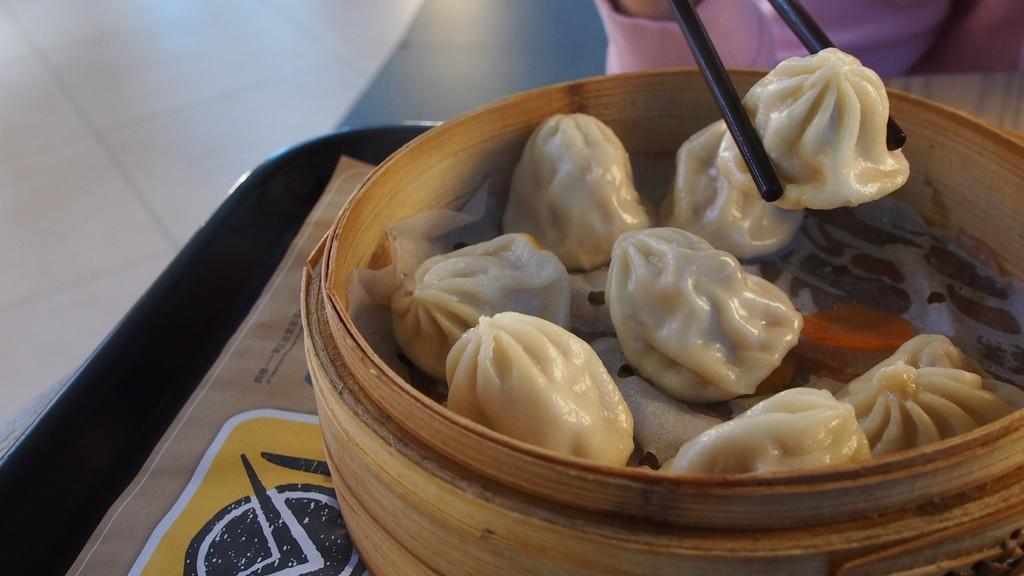Please provide a concise description of this image. In this image there is a table and we can see a basket containing momos. On the right we can see a person holding chopsticks. In the background there is a floor. 